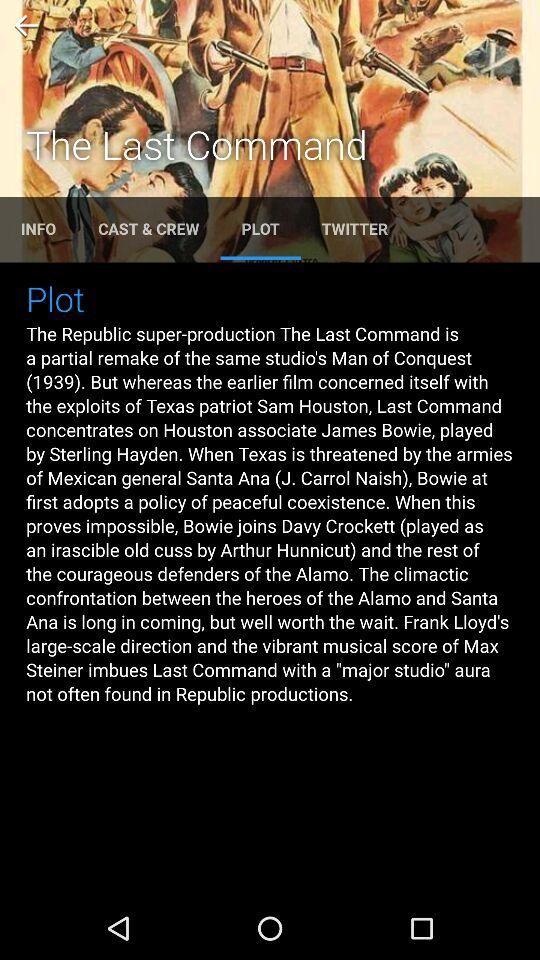What is the name of the film? The name of the film is "The Last Command". 